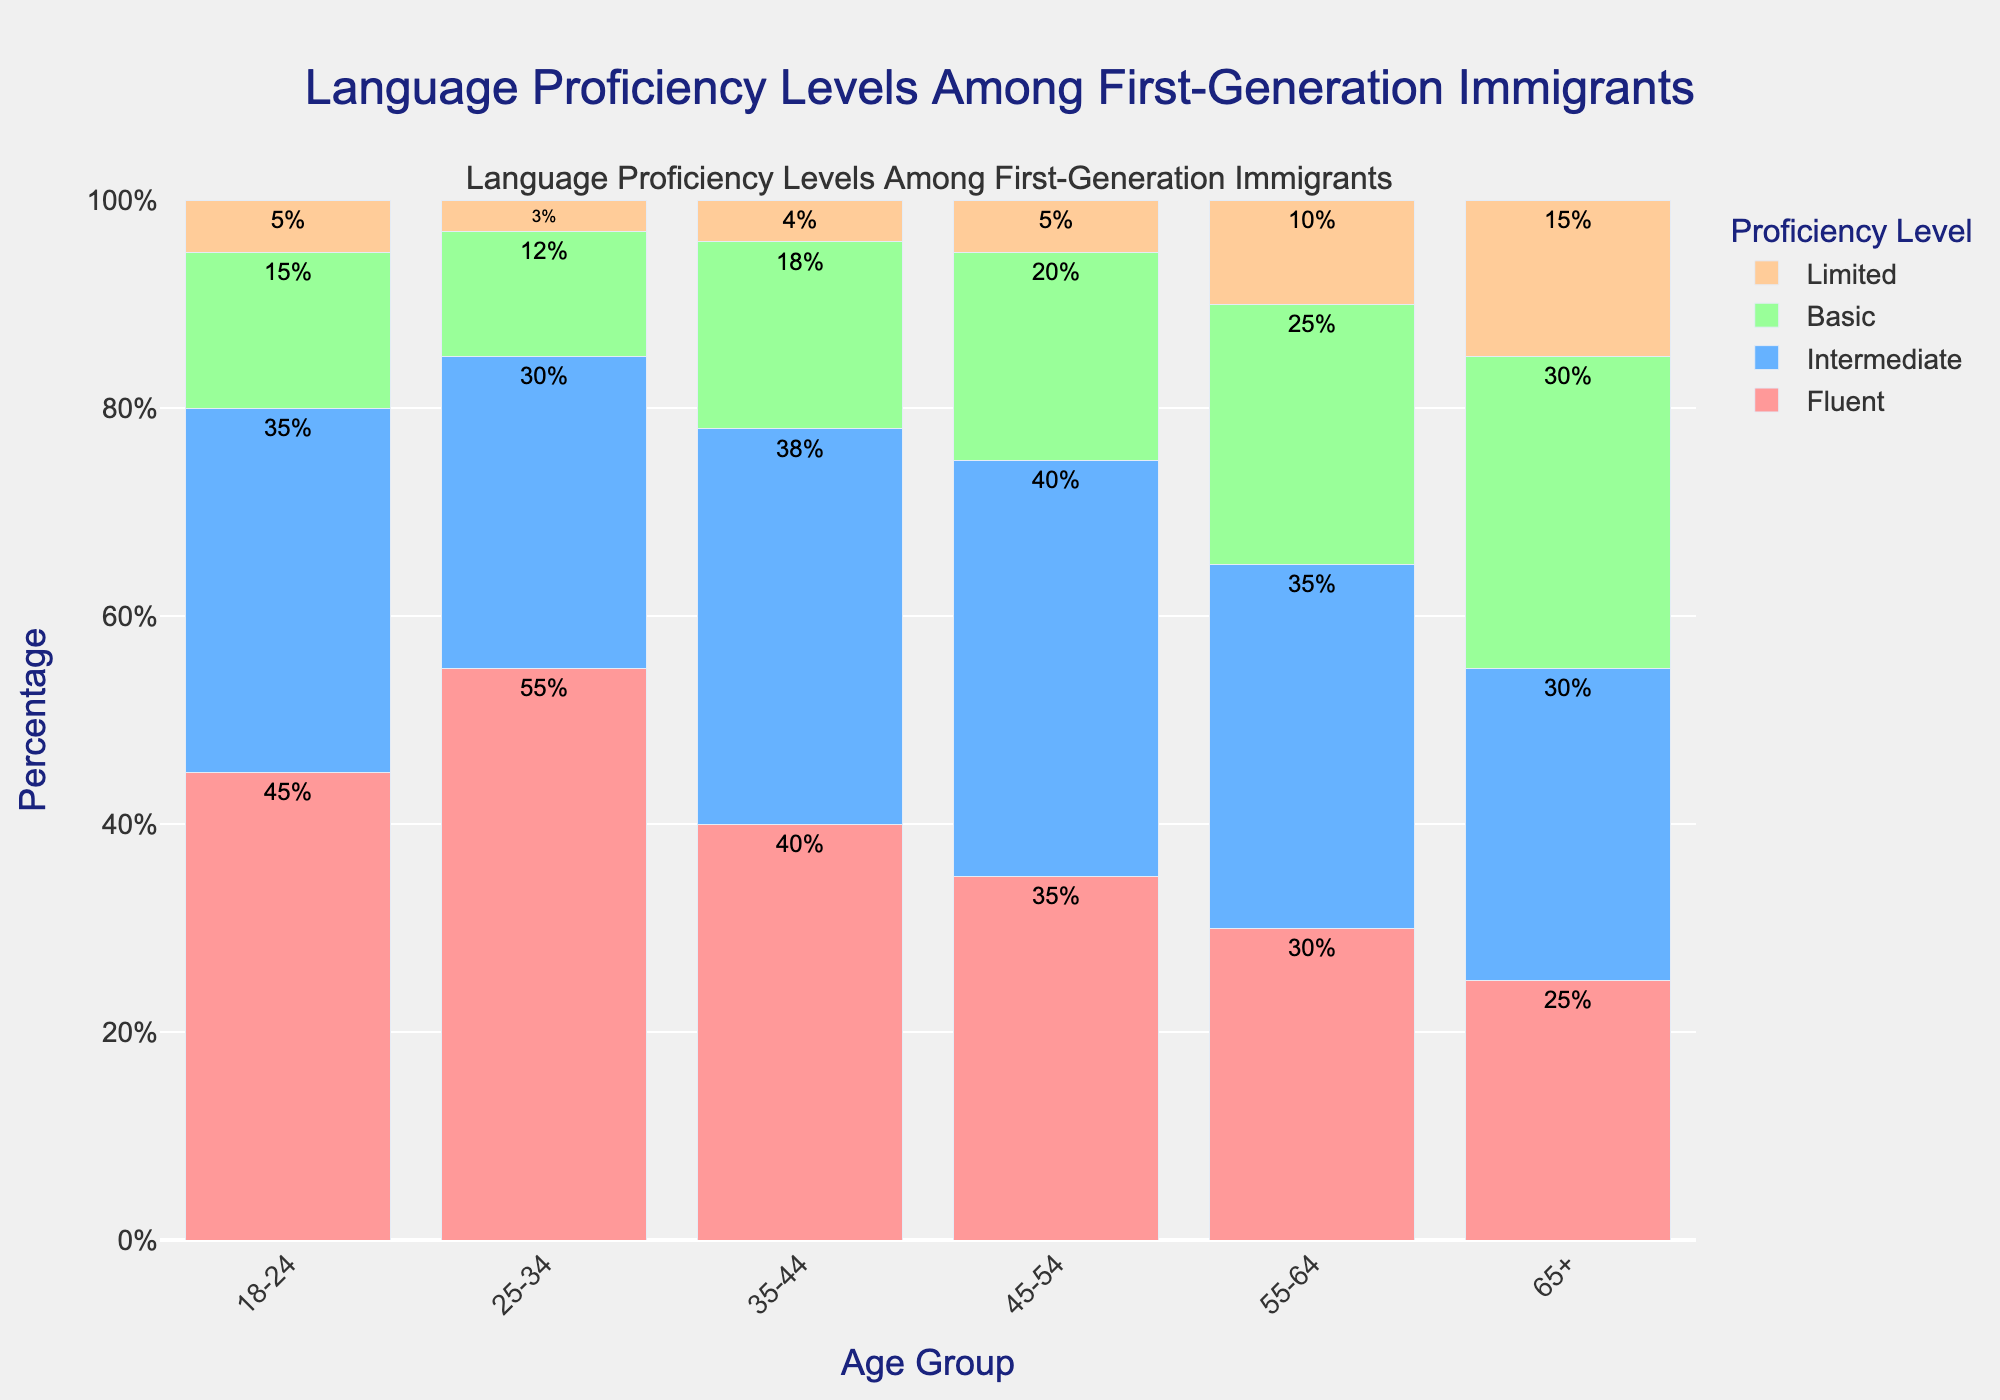Which age group has the highest percentage of fluent speakers? To determine this, we look at the heights of the bars corresponding to the 'Fluent' category for each age group. The age group 25-34 has the highest bar at 55%.
Answer: 25-34 What is the total percentage of limited speakers across all age groups? Add the percentages of 'Limited' speakers for each age group: 5 + 3 + 4 + 5 + 10 + 15 = 42%.
Answer: 42% How does the percentage of intermediate speakers in the 55-64 age group compare to that in the 65+ age group? Looking at the bars for the 'Intermediate' category, the 55-64 age group has 35% and the 65+ age group has 30%.
Answer: 55-64 has 5% more What is the difference in the percentage of basic speakers between the 18-24 and 65+ age groups? The 18-24 age group has 15% basic speakers, and the 65+ age group has 30%. Thus, the difference is 30% - 15% = 15%.
Answer: 15% Which age group has the most evenly distributed language proficiency levels? The age group with the most evenly distributed bars of similar height in all categories is 65+, having values of 25%, 30%, 30%, and 15%.
Answer: 65+ What is the total percentage of fluent and intermediate speakers in the 35-44 age group? Add the percentages for 'Fluent' and 'Intermediate': 40% + 38% = 78%.
Answer: 78% Which proficiency level shows the least variation across all age groups? By comparing the bar heights for each proficiency level across different age groups, 'Limited' shows the least variation with values ranging from 3% to 15%.
Answer: Limited What is the average percentage of basic speakers across all age groups? Add the percentages for 'Basic' across all age groups and divide by the number of age groups: (15 + 12 + 18 + 20 + 25 + 30) / 6 = 120 / 6 = 20%.
Answer: 20% How do the percentages of fluent and basic speakers in the 25-34 age group compare? In the 25-34 age group, fluent speakers are at 55% and basic speakers are at 12%, so fluent speakers are more by 55% - 12% = 43%.
Answer: Fluent is 43% more 